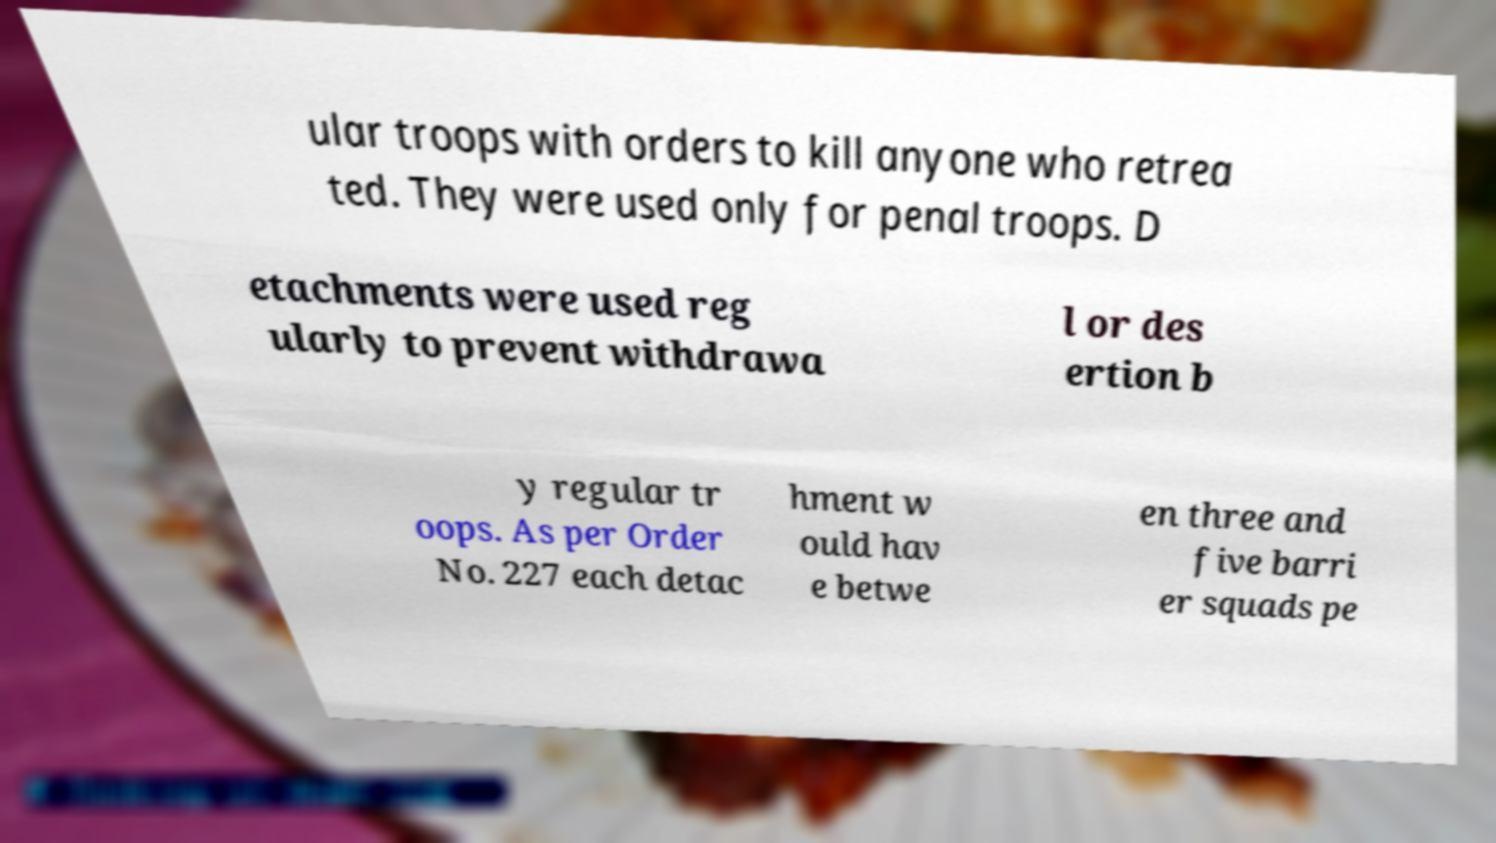Please identify and transcribe the text found in this image. ular troops with orders to kill anyone who retrea ted. They were used only for penal troops. D etachments were used reg ularly to prevent withdrawa l or des ertion b y regular tr oops. As per Order No. 227 each detac hment w ould hav e betwe en three and five barri er squads pe 